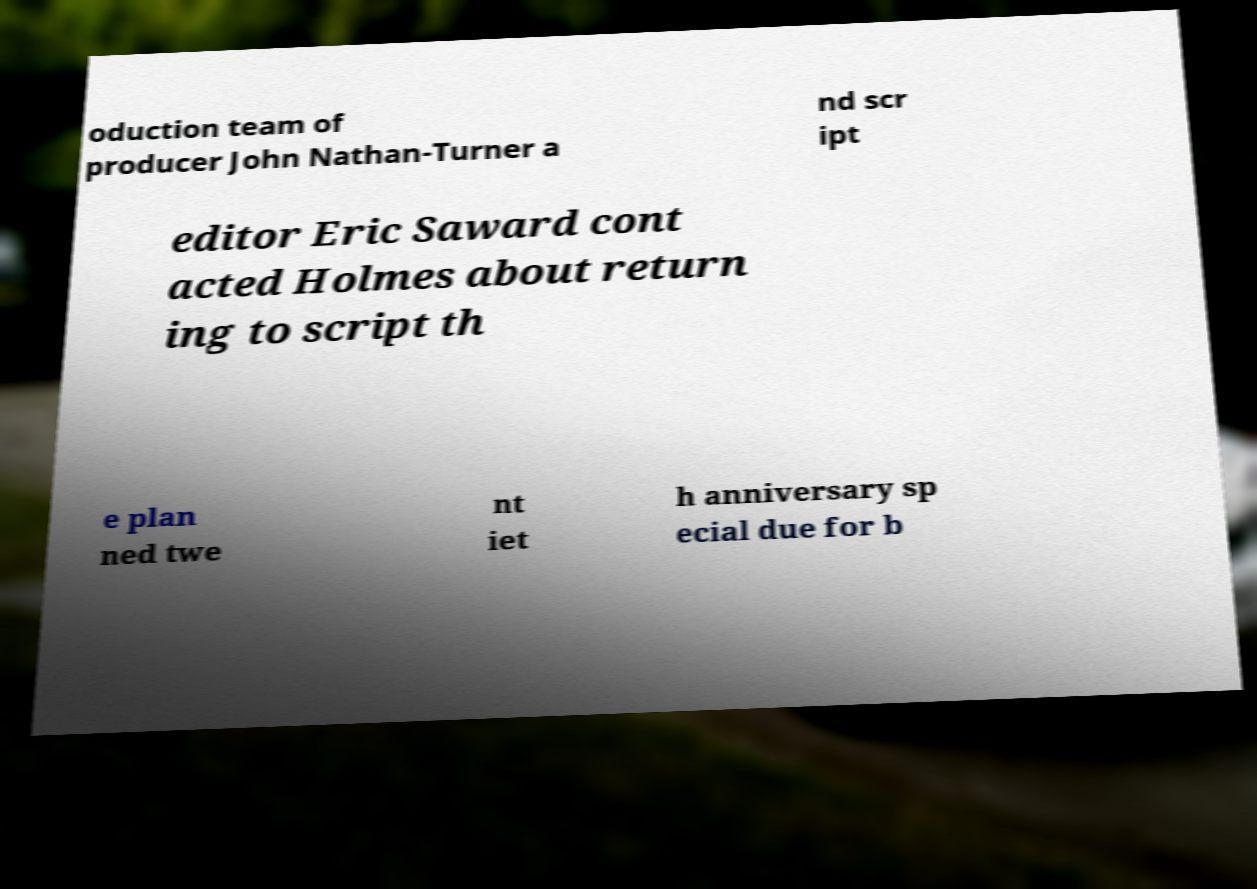Can you accurately transcribe the text from the provided image for me? oduction team of producer John Nathan-Turner a nd scr ipt editor Eric Saward cont acted Holmes about return ing to script th e plan ned twe nt iet h anniversary sp ecial due for b 